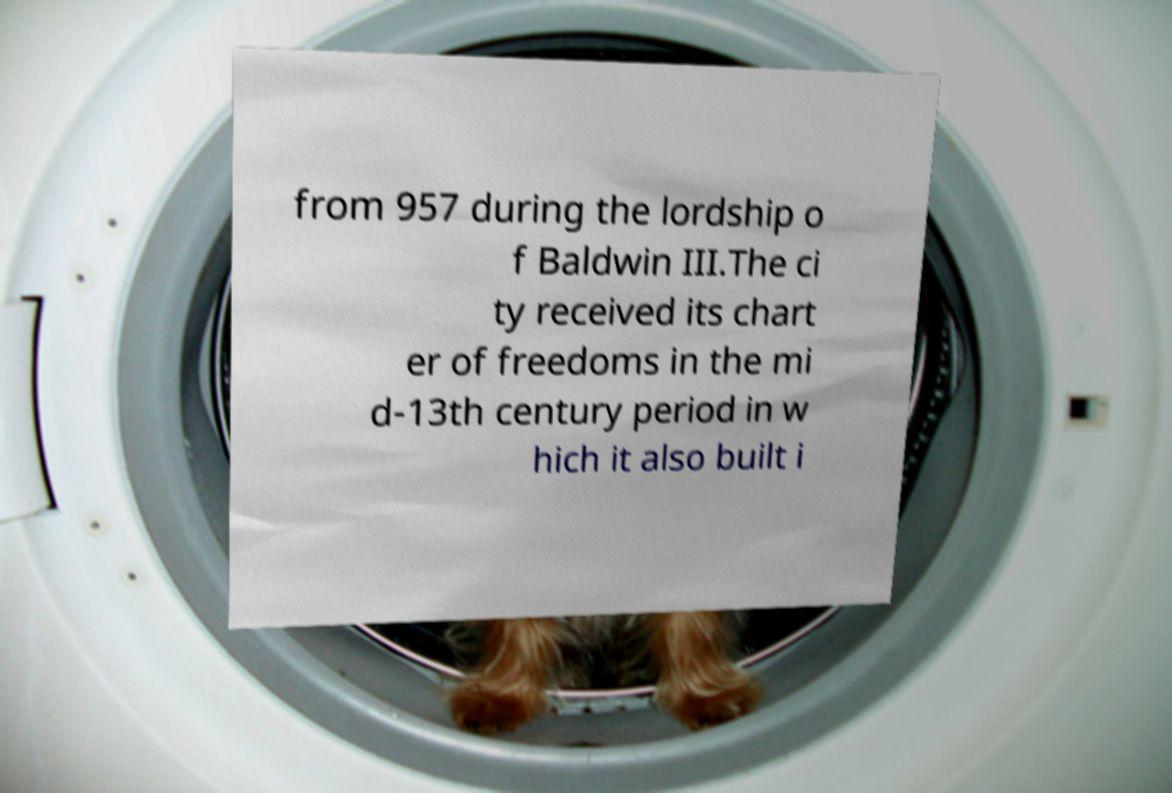What messages or text are displayed in this image? I need them in a readable, typed format. from 957 during the lordship o f Baldwin III.The ci ty received its chart er of freedoms in the mi d-13th century period in w hich it also built i 